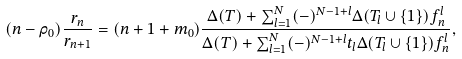<formula> <loc_0><loc_0><loc_500><loc_500>( n - \rho _ { 0 } ) \frac { r _ { n } } { r _ { n + 1 } } = ( n + 1 + m _ { 0 } ) \frac { \Delta ( T ) + \sum ^ { N } _ { l = 1 } ( - ) ^ { N - 1 + l } \Delta ( T _ { l } \cup \{ 1 \} ) f ^ { l } _ { n } } { \Delta ( T ) + \sum ^ { N } _ { l = 1 } ( - ) ^ { N - 1 + l } t _ { l } \Delta ( T _ { l } \cup \{ 1 \} ) f ^ { l } _ { n } } ,</formula> 